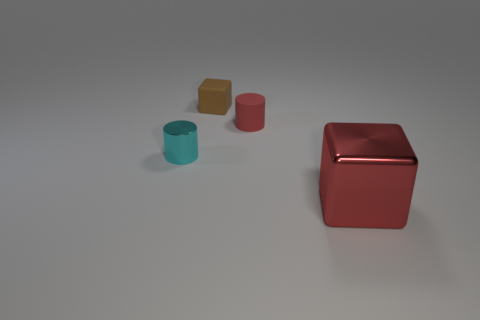How would you describe the surface on which the objects are placed? The objects are placed on a flat, smooth surface with a matte texture, which gives it a slightly reflective appearance. 